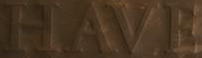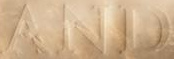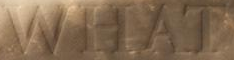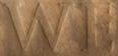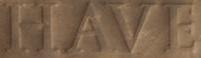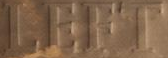What words are shown in these images in order, separated by a semicolon? HAVE; AND; WHAT; WE; HAVE; LEFT 